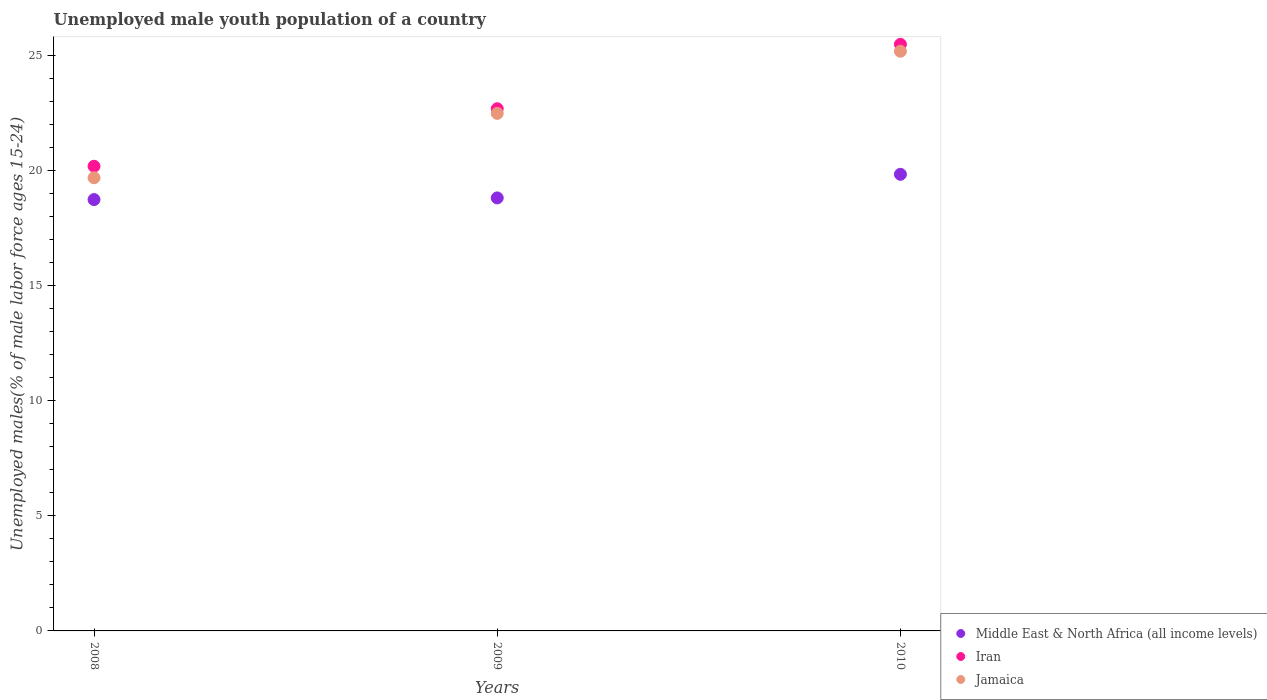How many different coloured dotlines are there?
Give a very brief answer. 3. Is the number of dotlines equal to the number of legend labels?
Provide a succinct answer. Yes. What is the percentage of unemployed male youth population in Iran in 2009?
Offer a terse response. 22.7. Across all years, what is the maximum percentage of unemployed male youth population in Middle East & North Africa (all income levels)?
Make the answer very short. 19.85. Across all years, what is the minimum percentage of unemployed male youth population in Jamaica?
Provide a succinct answer. 19.7. In which year was the percentage of unemployed male youth population in Jamaica minimum?
Give a very brief answer. 2008. What is the total percentage of unemployed male youth population in Jamaica in the graph?
Your answer should be very brief. 67.4. What is the difference between the percentage of unemployed male youth population in Middle East & North Africa (all income levels) in 2009 and that in 2010?
Provide a succinct answer. -1.03. What is the difference between the percentage of unemployed male youth population in Middle East & North Africa (all income levels) in 2008 and the percentage of unemployed male youth population in Jamaica in 2009?
Your answer should be very brief. -3.75. What is the average percentage of unemployed male youth population in Jamaica per year?
Your answer should be compact. 22.47. In the year 2010, what is the difference between the percentage of unemployed male youth population in Jamaica and percentage of unemployed male youth population in Iran?
Give a very brief answer. -0.3. In how many years, is the percentage of unemployed male youth population in Iran greater than 2 %?
Provide a succinct answer. 3. What is the ratio of the percentage of unemployed male youth population in Iran in 2008 to that in 2009?
Your answer should be compact. 0.89. Is the percentage of unemployed male youth population in Iran in 2009 less than that in 2010?
Give a very brief answer. Yes. Is the difference between the percentage of unemployed male youth population in Jamaica in 2008 and 2010 greater than the difference between the percentage of unemployed male youth population in Iran in 2008 and 2010?
Provide a succinct answer. No. What is the difference between the highest and the second highest percentage of unemployed male youth population in Jamaica?
Your answer should be compact. 2.7. What is the difference between the highest and the lowest percentage of unemployed male youth population in Jamaica?
Offer a terse response. 5.5. Is it the case that in every year, the sum of the percentage of unemployed male youth population in Jamaica and percentage of unemployed male youth population in Middle East & North Africa (all income levels)  is greater than the percentage of unemployed male youth population in Iran?
Provide a succinct answer. Yes. Does the percentage of unemployed male youth population in Iran monotonically increase over the years?
Offer a very short reply. Yes. Is the percentage of unemployed male youth population in Iran strictly greater than the percentage of unemployed male youth population in Jamaica over the years?
Keep it short and to the point. Yes. How many dotlines are there?
Keep it short and to the point. 3. How many years are there in the graph?
Keep it short and to the point. 3. What is the title of the graph?
Make the answer very short. Unemployed male youth population of a country. What is the label or title of the Y-axis?
Keep it short and to the point. Unemployed males(% of male labor force ages 15-24). What is the Unemployed males(% of male labor force ages 15-24) of Middle East & North Africa (all income levels) in 2008?
Your answer should be compact. 18.75. What is the Unemployed males(% of male labor force ages 15-24) in Iran in 2008?
Keep it short and to the point. 20.2. What is the Unemployed males(% of male labor force ages 15-24) of Jamaica in 2008?
Your answer should be compact. 19.7. What is the Unemployed males(% of male labor force ages 15-24) of Middle East & North Africa (all income levels) in 2009?
Keep it short and to the point. 18.82. What is the Unemployed males(% of male labor force ages 15-24) in Iran in 2009?
Your response must be concise. 22.7. What is the Unemployed males(% of male labor force ages 15-24) of Jamaica in 2009?
Provide a short and direct response. 22.5. What is the Unemployed males(% of male labor force ages 15-24) of Middle East & North Africa (all income levels) in 2010?
Make the answer very short. 19.85. What is the Unemployed males(% of male labor force ages 15-24) of Jamaica in 2010?
Provide a short and direct response. 25.2. Across all years, what is the maximum Unemployed males(% of male labor force ages 15-24) in Middle East & North Africa (all income levels)?
Your answer should be very brief. 19.85. Across all years, what is the maximum Unemployed males(% of male labor force ages 15-24) of Iran?
Ensure brevity in your answer.  25.5. Across all years, what is the maximum Unemployed males(% of male labor force ages 15-24) in Jamaica?
Make the answer very short. 25.2. Across all years, what is the minimum Unemployed males(% of male labor force ages 15-24) in Middle East & North Africa (all income levels)?
Make the answer very short. 18.75. Across all years, what is the minimum Unemployed males(% of male labor force ages 15-24) in Iran?
Give a very brief answer. 20.2. Across all years, what is the minimum Unemployed males(% of male labor force ages 15-24) of Jamaica?
Make the answer very short. 19.7. What is the total Unemployed males(% of male labor force ages 15-24) of Middle East & North Africa (all income levels) in the graph?
Offer a very short reply. 57.43. What is the total Unemployed males(% of male labor force ages 15-24) in Iran in the graph?
Your response must be concise. 68.4. What is the total Unemployed males(% of male labor force ages 15-24) in Jamaica in the graph?
Your response must be concise. 67.4. What is the difference between the Unemployed males(% of male labor force ages 15-24) of Middle East & North Africa (all income levels) in 2008 and that in 2009?
Give a very brief answer. -0.07. What is the difference between the Unemployed males(% of male labor force ages 15-24) of Iran in 2008 and that in 2009?
Provide a short and direct response. -2.5. What is the difference between the Unemployed males(% of male labor force ages 15-24) of Middle East & North Africa (all income levels) in 2008 and that in 2010?
Offer a very short reply. -1.1. What is the difference between the Unemployed males(% of male labor force ages 15-24) in Middle East & North Africa (all income levels) in 2009 and that in 2010?
Offer a terse response. -1.03. What is the difference between the Unemployed males(% of male labor force ages 15-24) in Iran in 2009 and that in 2010?
Your answer should be compact. -2.8. What is the difference between the Unemployed males(% of male labor force ages 15-24) of Middle East & North Africa (all income levels) in 2008 and the Unemployed males(% of male labor force ages 15-24) of Iran in 2009?
Your answer should be very brief. -3.95. What is the difference between the Unemployed males(% of male labor force ages 15-24) in Middle East & North Africa (all income levels) in 2008 and the Unemployed males(% of male labor force ages 15-24) in Jamaica in 2009?
Ensure brevity in your answer.  -3.75. What is the difference between the Unemployed males(% of male labor force ages 15-24) in Iran in 2008 and the Unemployed males(% of male labor force ages 15-24) in Jamaica in 2009?
Keep it short and to the point. -2.3. What is the difference between the Unemployed males(% of male labor force ages 15-24) in Middle East & North Africa (all income levels) in 2008 and the Unemployed males(% of male labor force ages 15-24) in Iran in 2010?
Make the answer very short. -6.75. What is the difference between the Unemployed males(% of male labor force ages 15-24) in Middle East & North Africa (all income levels) in 2008 and the Unemployed males(% of male labor force ages 15-24) in Jamaica in 2010?
Ensure brevity in your answer.  -6.45. What is the difference between the Unemployed males(% of male labor force ages 15-24) of Iran in 2008 and the Unemployed males(% of male labor force ages 15-24) of Jamaica in 2010?
Offer a very short reply. -5. What is the difference between the Unemployed males(% of male labor force ages 15-24) of Middle East & North Africa (all income levels) in 2009 and the Unemployed males(% of male labor force ages 15-24) of Iran in 2010?
Give a very brief answer. -6.68. What is the difference between the Unemployed males(% of male labor force ages 15-24) in Middle East & North Africa (all income levels) in 2009 and the Unemployed males(% of male labor force ages 15-24) in Jamaica in 2010?
Provide a short and direct response. -6.38. What is the difference between the Unemployed males(% of male labor force ages 15-24) in Iran in 2009 and the Unemployed males(% of male labor force ages 15-24) in Jamaica in 2010?
Keep it short and to the point. -2.5. What is the average Unemployed males(% of male labor force ages 15-24) in Middle East & North Africa (all income levels) per year?
Give a very brief answer. 19.14. What is the average Unemployed males(% of male labor force ages 15-24) of Iran per year?
Give a very brief answer. 22.8. What is the average Unemployed males(% of male labor force ages 15-24) in Jamaica per year?
Your answer should be very brief. 22.47. In the year 2008, what is the difference between the Unemployed males(% of male labor force ages 15-24) in Middle East & North Africa (all income levels) and Unemployed males(% of male labor force ages 15-24) in Iran?
Provide a short and direct response. -1.45. In the year 2008, what is the difference between the Unemployed males(% of male labor force ages 15-24) of Middle East & North Africa (all income levels) and Unemployed males(% of male labor force ages 15-24) of Jamaica?
Offer a very short reply. -0.95. In the year 2008, what is the difference between the Unemployed males(% of male labor force ages 15-24) in Iran and Unemployed males(% of male labor force ages 15-24) in Jamaica?
Provide a short and direct response. 0.5. In the year 2009, what is the difference between the Unemployed males(% of male labor force ages 15-24) in Middle East & North Africa (all income levels) and Unemployed males(% of male labor force ages 15-24) in Iran?
Offer a very short reply. -3.88. In the year 2009, what is the difference between the Unemployed males(% of male labor force ages 15-24) of Middle East & North Africa (all income levels) and Unemployed males(% of male labor force ages 15-24) of Jamaica?
Provide a succinct answer. -3.68. In the year 2010, what is the difference between the Unemployed males(% of male labor force ages 15-24) of Middle East & North Africa (all income levels) and Unemployed males(% of male labor force ages 15-24) of Iran?
Offer a very short reply. -5.65. In the year 2010, what is the difference between the Unemployed males(% of male labor force ages 15-24) in Middle East & North Africa (all income levels) and Unemployed males(% of male labor force ages 15-24) in Jamaica?
Offer a terse response. -5.35. What is the ratio of the Unemployed males(% of male labor force ages 15-24) in Middle East & North Africa (all income levels) in 2008 to that in 2009?
Give a very brief answer. 1. What is the ratio of the Unemployed males(% of male labor force ages 15-24) of Iran in 2008 to that in 2009?
Your answer should be compact. 0.89. What is the ratio of the Unemployed males(% of male labor force ages 15-24) of Jamaica in 2008 to that in 2009?
Offer a very short reply. 0.88. What is the ratio of the Unemployed males(% of male labor force ages 15-24) in Middle East & North Africa (all income levels) in 2008 to that in 2010?
Make the answer very short. 0.94. What is the ratio of the Unemployed males(% of male labor force ages 15-24) of Iran in 2008 to that in 2010?
Offer a terse response. 0.79. What is the ratio of the Unemployed males(% of male labor force ages 15-24) in Jamaica in 2008 to that in 2010?
Your answer should be very brief. 0.78. What is the ratio of the Unemployed males(% of male labor force ages 15-24) in Middle East & North Africa (all income levels) in 2009 to that in 2010?
Offer a terse response. 0.95. What is the ratio of the Unemployed males(% of male labor force ages 15-24) of Iran in 2009 to that in 2010?
Offer a terse response. 0.89. What is the ratio of the Unemployed males(% of male labor force ages 15-24) in Jamaica in 2009 to that in 2010?
Ensure brevity in your answer.  0.89. What is the difference between the highest and the second highest Unemployed males(% of male labor force ages 15-24) in Middle East & North Africa (all income levels)?
Your answer should be compact. 1.03. What is the difference between the highest and the second highest Unemployed males(% of male labor force ages 15-24) in Iran?
Make the answer very short. 2.8. What is the difference between the highest and the lowest Unemployed males(% of male labor force ages 15-24) in Middle East & North Africa (all income levels)?
Your answer should be compact. 1.1. What is the difference between the highest and the lowest Unemployed males(% of male labor force ages 15-24) in Jamaica?
Your answer should be very brief. 5.5. 